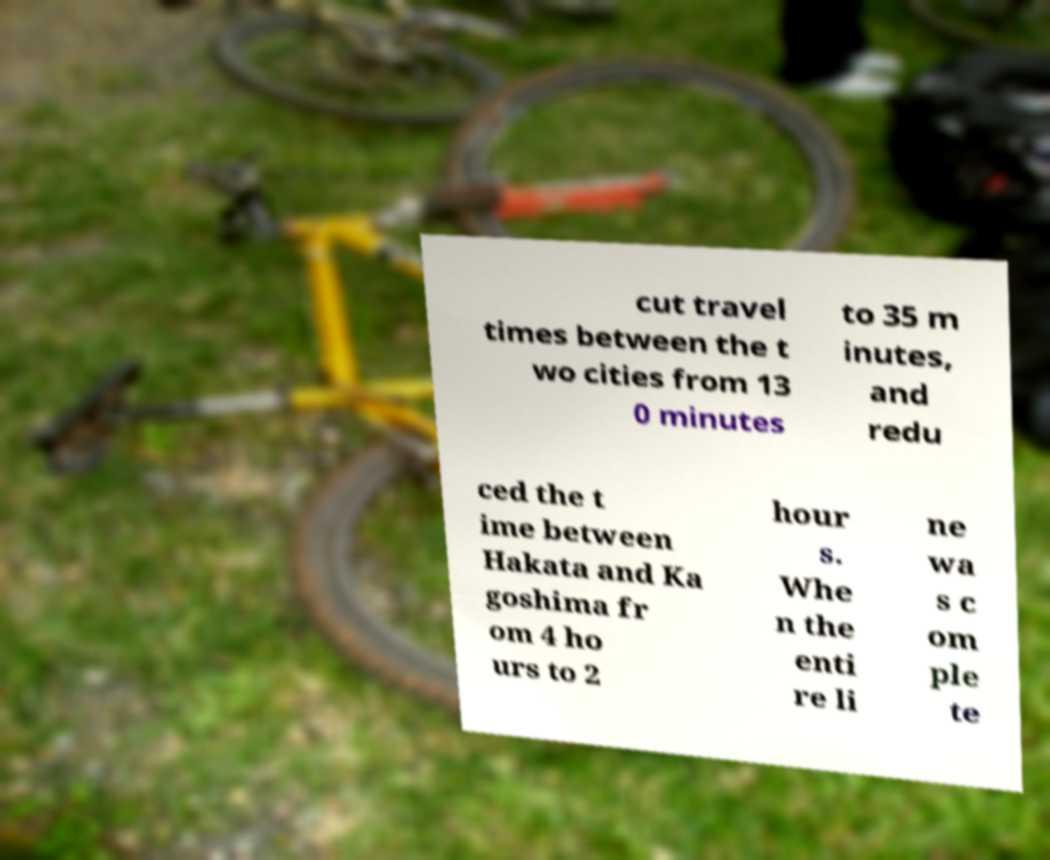Please identify and transcribe the text found in this image. cut travel times between the t wo cities from 13 0 minutes to 35 m inutes, and redu ced the t ime between Hakata and Ka goshima fr om 4 ho urs to 2 hour s. Whe n the enti re li ne wa s c om ple te 